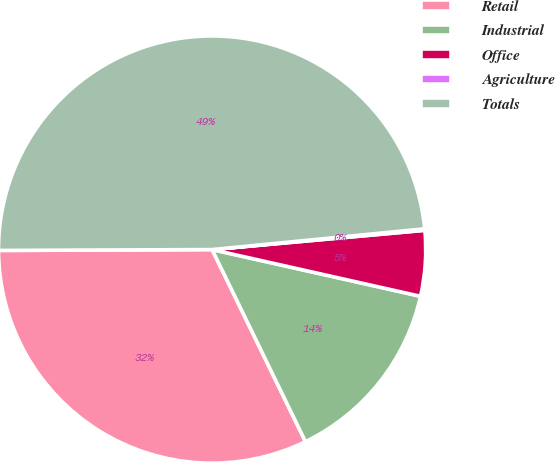Convert chart to OTSL. <chart><loc_0><loc_0><loc_500><loc_500><pie_chart><fcel>Retail<fcel>Industrial<fcel>Office<fcel>Agriculture<fcel>Totals<nl><fcel>32.14%<fcel>14.29%<fcel>4.95%<fcel>0.11%<fcel>48.52%<nl></chart> 